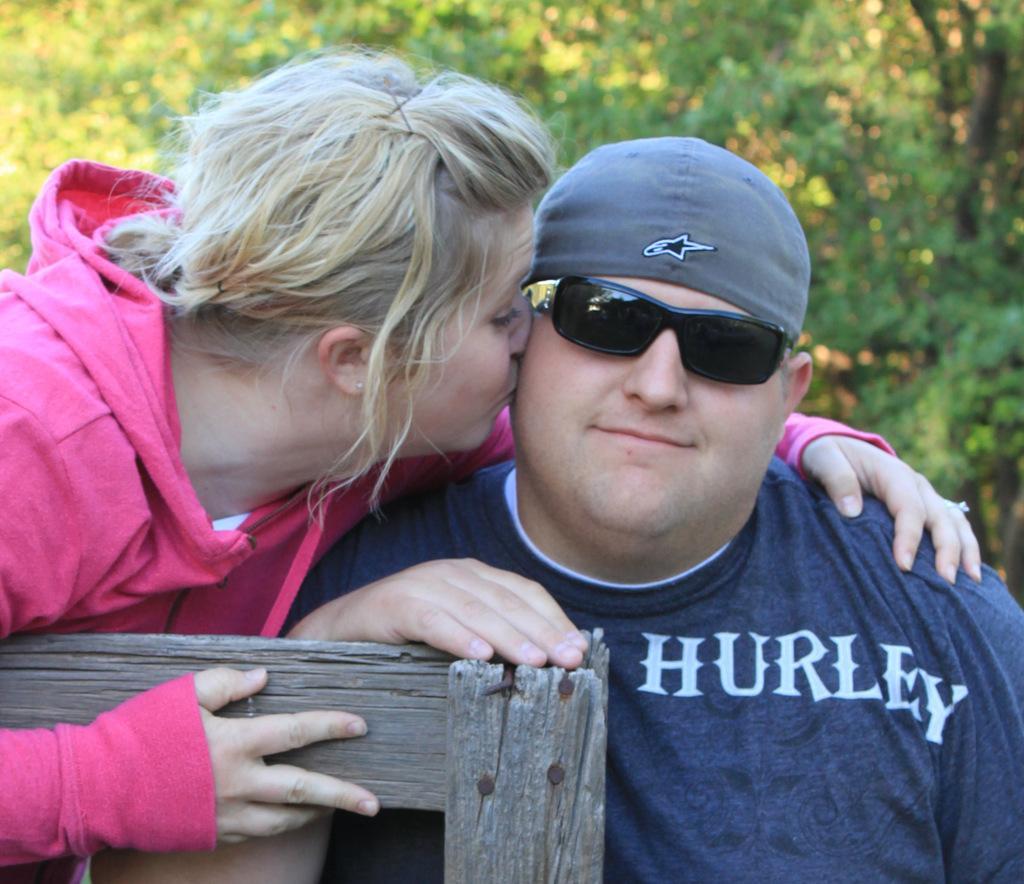Describe this image in one or two sentences. In this image I can see two persons, the person at right is wearing blue color shirt and the person at left is wearing pink color jacket. In front I can see the wooden object. In the background the trees are in green color. 